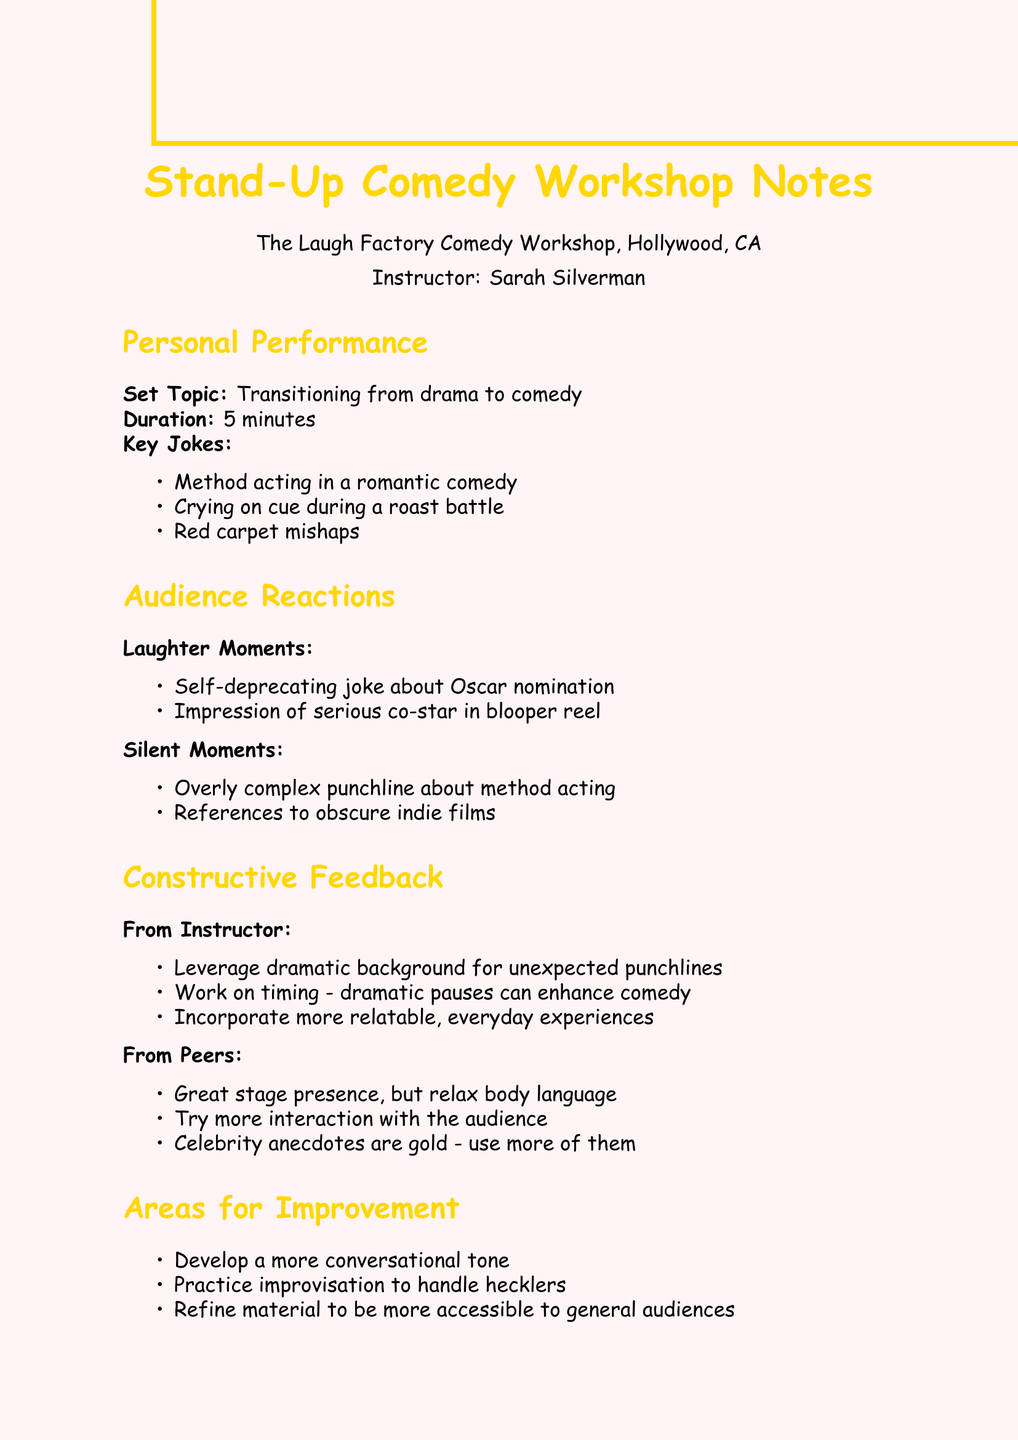What is the name of the workshop? The document states the workshop is called "The Laugh Factory Comedy Workshop."
Answer: The Laugh Factory Comedy Workshop Who was the instructor? According to the document, the instructor for the workshop was Sarah Silverman.
Answer: Sarah Silverman What was the duration of the performance? The duration mentioned for the personal performance in the document is 5 minutes.
Answer: 5 minutes What kind of jokes does the personal performance include? The document lists key jokes such as "Method acting in a romantic comedy."
Answer: Method acting in a romantic comedy How did the audience react to the self-deprecating joke? The document notes that the audience had laughter moments, indicating a positive reaction.
Answer: Laughter What is one area for improvement noted in the document? The document mentions developing a more conversational tone as an area for improvement.
Answer: More conversational tone What is one next step suggested in the notes? The document states that booking open mic nights at The Comedy Store is a suggested next step.
Answer: Book open mic nights at The Comedy Store What type of feedback did peers provide? The document indicates that peers appreciated the stage presence but suggested relaxing body language.
Answer: Relax body language What was a silent moment during the performance? The document mentions an overly complex punchline about method acting as a silent moment.
Answer: Overly complex punchline about method acting 